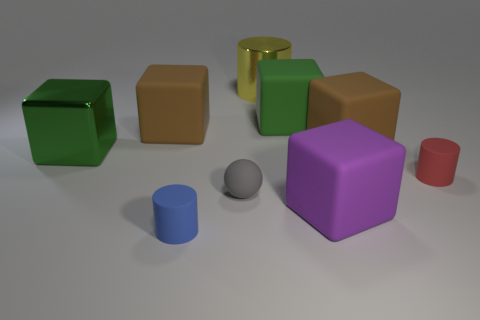How many blocks are either big blue things or small gray matte things?
Give a very brief answer. 0. There is a brown object to the left of the tiny blue rubber cylinder; what is its material?
Your answer should be very brief. Rubber. Are there fewer big yellow metal cubes than green things?
Your response must be concise. Yes. There is a matte object that is to the left of the gray object and behind the blue matte cylinder; what is its size?
Offer a very short reply. Large. There is a yellow shiny thing behind the small rubber cylinder that is right of the large matte block that is in front of the big shiny cube; what size is it?
Your answer should be very brief. Large. How many other things are the same color as the big metal cube?
Your response must be concise. 1. There is a small rubber cylinder behind the small gray thing; does it have the same color as the metallic cube?
Offer a terse response. No. What number of objects are either brown rubber cubes or large brown cylinders?
Your answer should be very brief. 2. What color is the rubber cylinder that is behind the purple block?
Offer a very short reply. Red. Is the number of big green objects right of the gray object less than the number of purple matte objects?
Keep it short and to the point. No. 